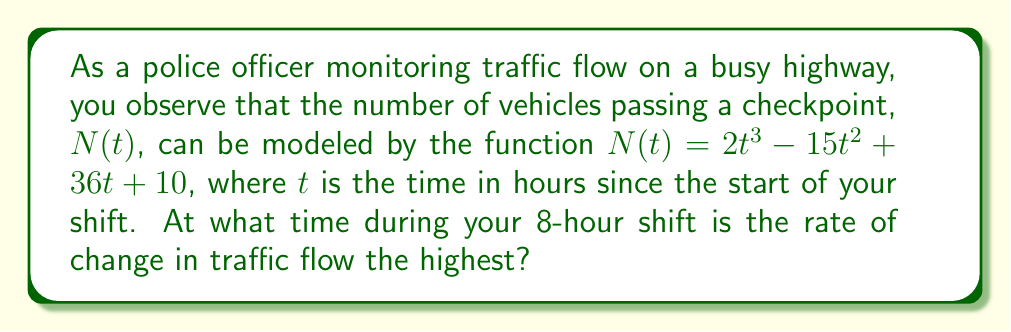Provide a solution to this math problem. To solve this problem, we need to follow these steps:

1) The rate of change in traffic flow is given by the first derivative of $N(t)$. Let's call this $N'(t)$.

   $N'(t) = \frac{d}{dt}(2t^3 - 15t^2 + 36t + 10)$
   $N'(t) = 6t^2 - 30t + 36$

2) To find when this rate of change is highest, we need to find the maximum of $N'(t)$. The maximum of a function occurs where its derivative is zero. So, we need to find the derivative of $N'(t)$, which is the second derivative of $N(t)$. Let's call this $N''(t)$.

   $N''(t) = \frac{d}{dt}(6t^2 - 30t + 36)$
   $N''(t) = 12t - 30$

3) Set $N''(t) = 0$ and solve for $t$:

   $12t - 30 = 0$
   $12t = 30$
   $t = \frac{30}{12} = 2.5$

4) To confirm this is a maximum (not a minimum), we can check that $N'''(t) < 0$:

   $N'''(t) = 12$, which is positive, so $t = 2.5$ gives a minimum for $N'(t)$, not a maximum.

5) Since we didn't find a maximum within the function, the maximum must occur at one of the endpoints of our domain. Our shift is 8 hours long, so we need to compare $N'(0)$ and $N'(8)$:

   $N'(0) = 36$
   $N'(8) = 6(8^2) - 30(8) + 36 = 384 - 240 + 36 = 180$

6) Since $N'(8) > N'(0)$, the rate of change is highest at $t = 8$.
Answer: 8 hours 